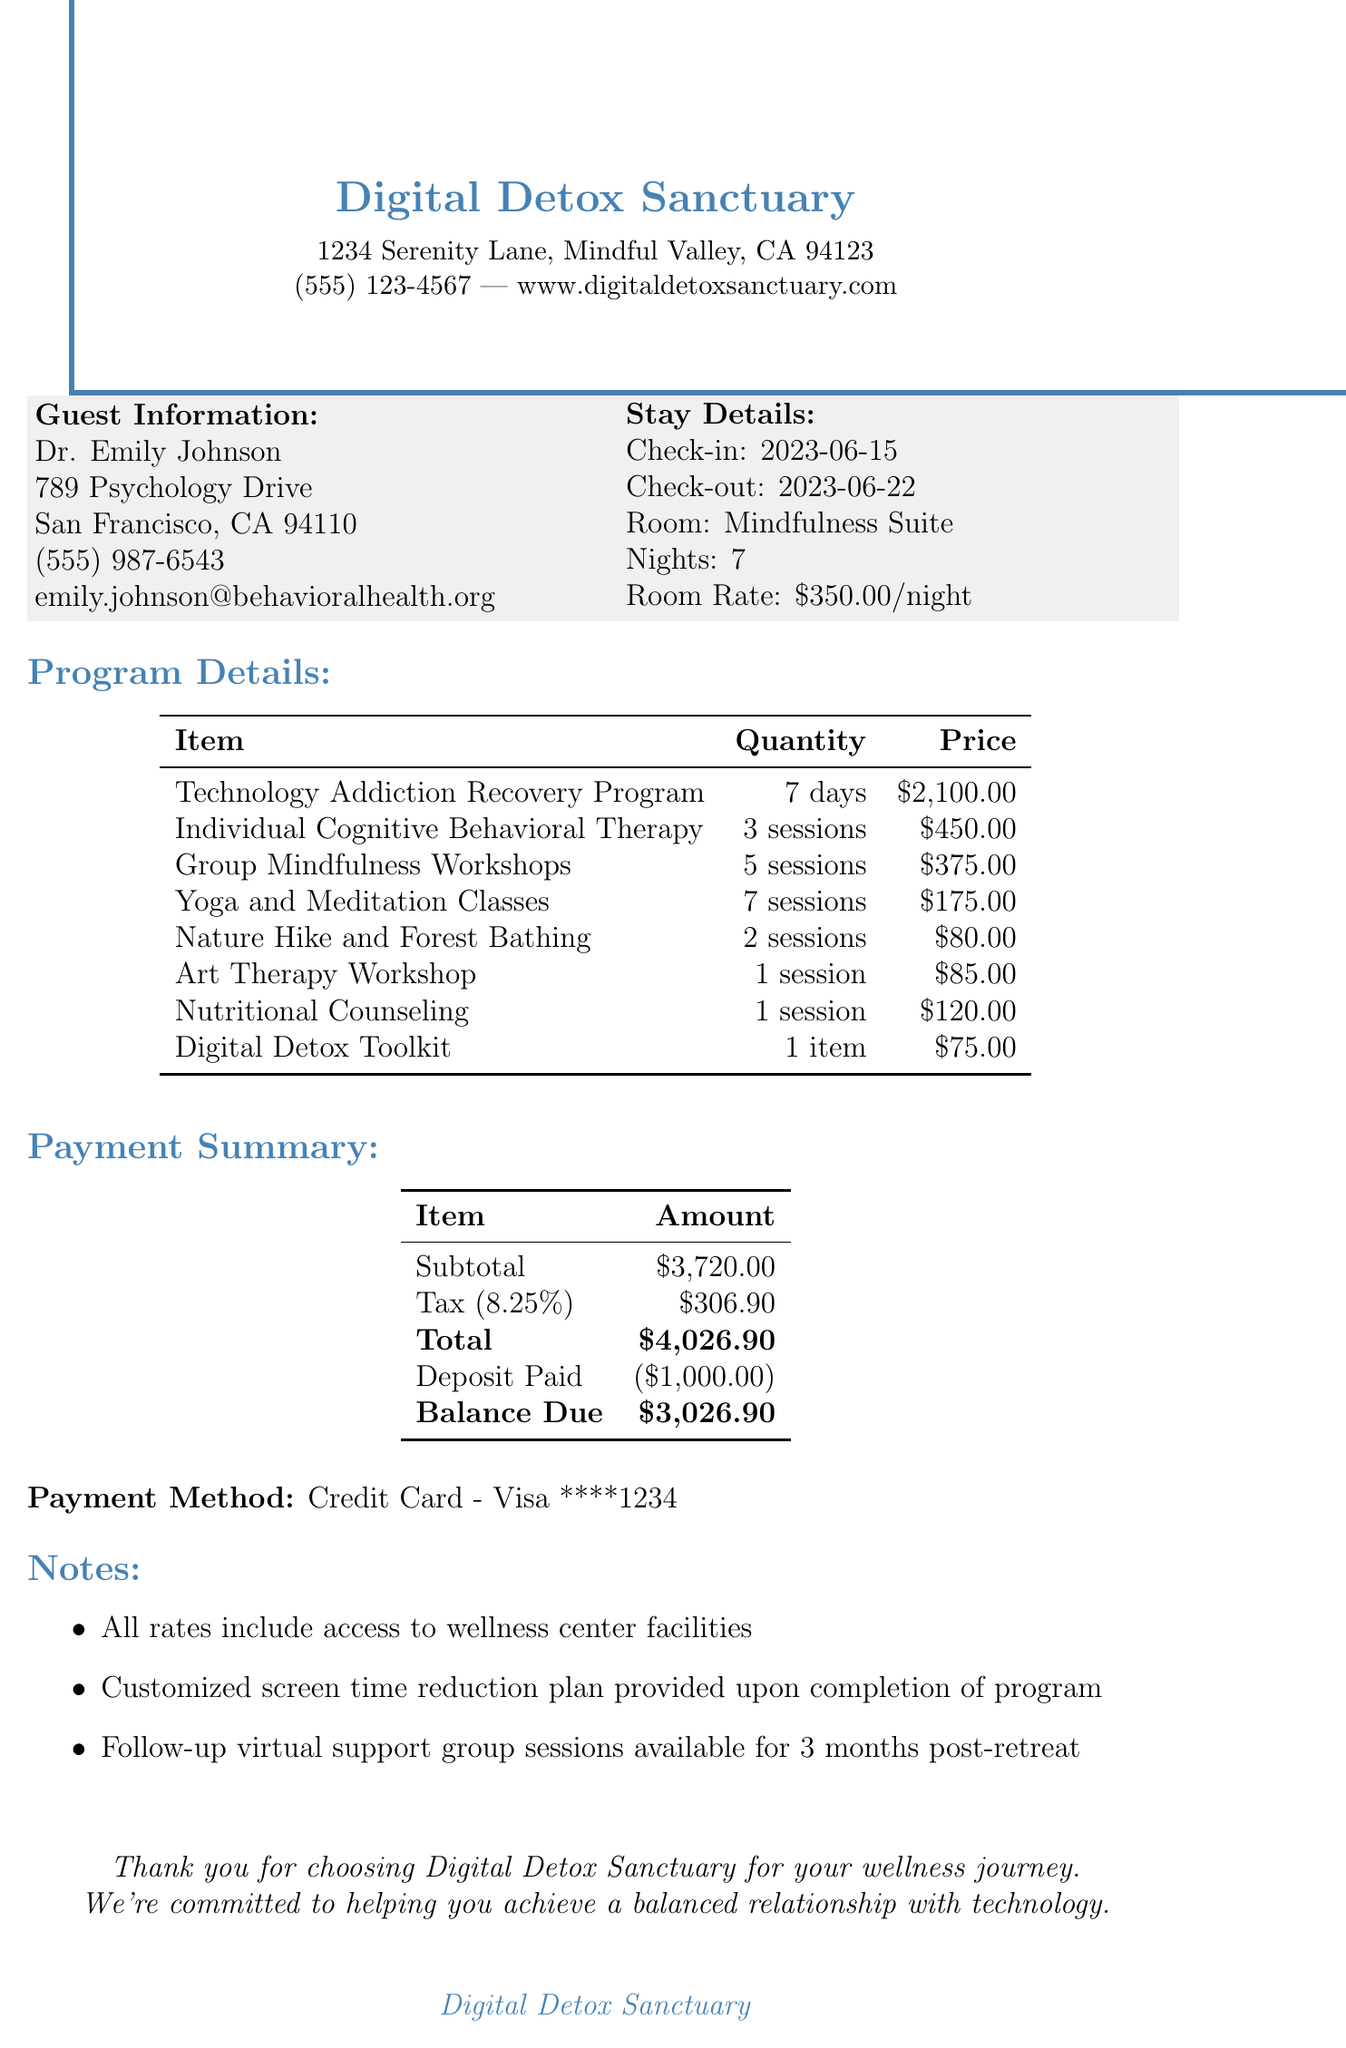What is the name of the retreat center? The name of the retreat center is provided in the document header.
Answer: Digital Detox Sanctuary What is the total amount owed after the deposit? The balance due is calculated by subtracting the deposit from the total amount.
Answer: $3,026.90 How many nights did Dr. Emily Johnson stay? The number of nights stayed is listed in the stay details section.
Answer: 7 What is the price per session for Individual Cognitive Behavioral Therapy? The price per session for Individual Cognitive Behavioral Therapy is explicitly stated in the program details.
Answer: $150.00 What wellness activity has the highest price per session? The highest-priced wellness activity is determined by comparing the prices per session listed in the wellness activities section.
Answer: Art Therapy Workshop When was the check-in date? The check-in date is provided in the stay details section of the document.
Answer: 2023-06-15 What is included in the Digital Detox Toolkit? The description of the Digital Detox Toolkit mentions its contents in the additional services section.
Answer: Journal, mindfulness cards, and screen time tracking app What type of therapy sessions are mentioned in the program details? The types of therapy sessions are specified in the program details section of the document.
Answer: Individual Cognitive Behavioral Therapy Sessions What is the tax rate applied to the subtotal? The tax rate is specified in the payment summary section of the document.
Answer: 0.0825 